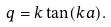Convert formula to latex. <formula><loc_0><loc_0><loc_500><loc_500>q = k \tan ( k a ) .</formula> 